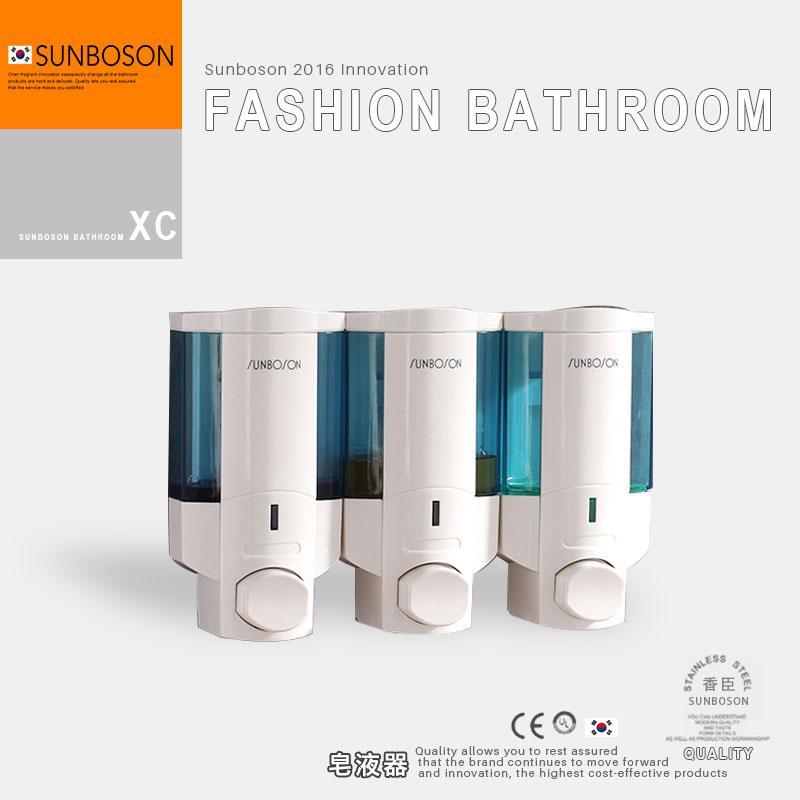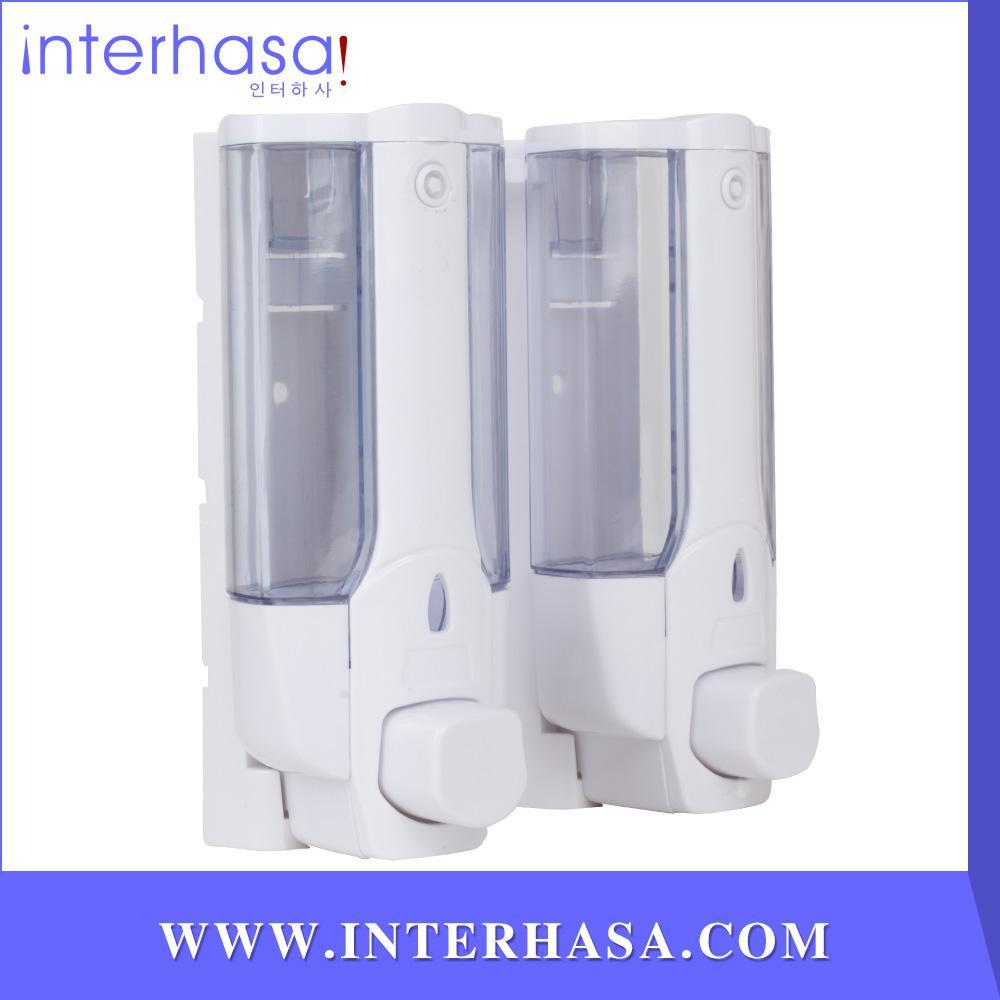The first image is the image on the left, the second image is the image on the right. Assess this claim about the two images: "A person is getting soap from a dispenser in the image on the right.". Correct or not? Answer yes or no. No. The first image is the image on the left, the second image is the image on the right. For the images shown, is this caption "There are exactly four dispensers, and at least of them are chrome." true? Answer yes or no. No. 